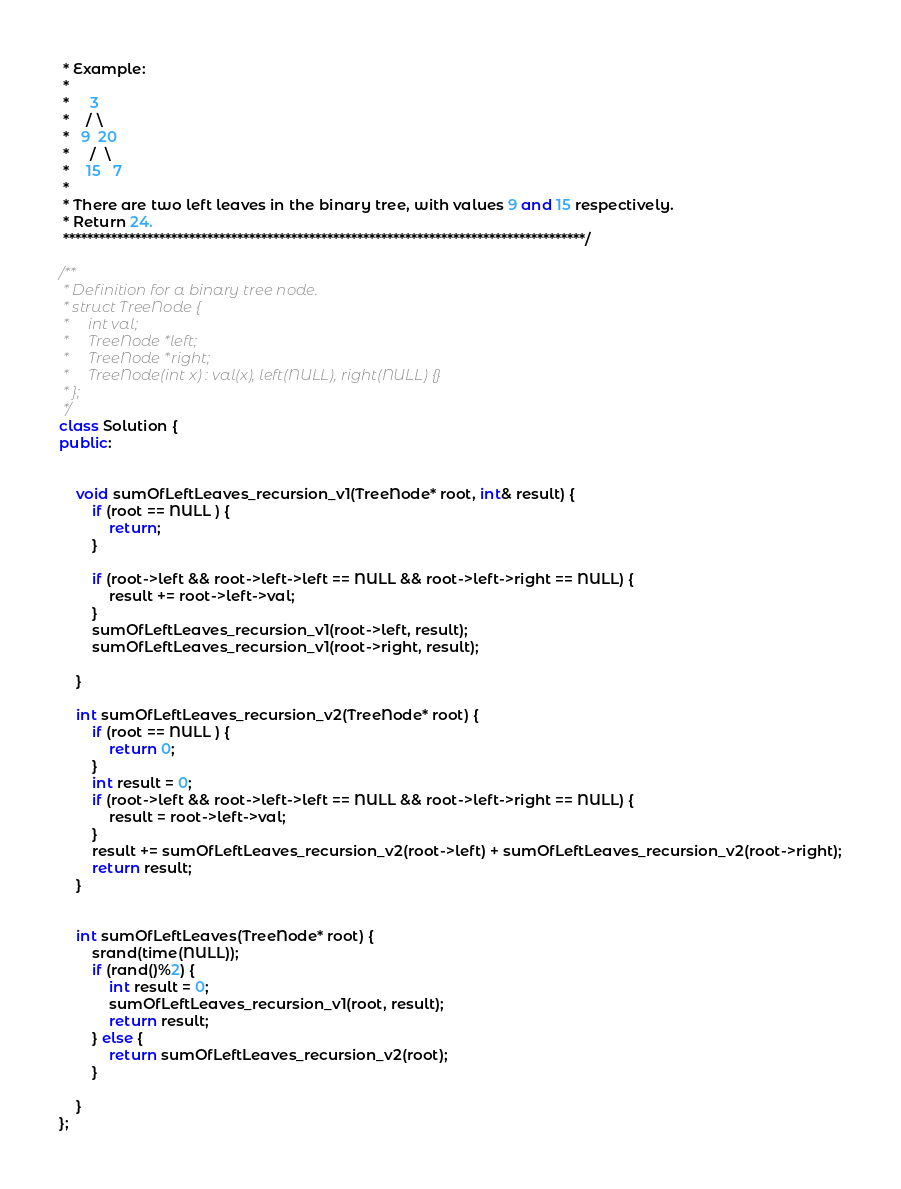Convert code to text. <code><loc_0><loc_0><loc_500><loc_500><_C++_> * Example:
 * 
 *     3
 *    / \
 *   9  20
 *     /  \
 *    15   7
 * 
 * There are two left leaves in the binary tree, with values 9 and 15 respectively. 
 * Return 24.
 ***************************************************************************************/

/**
 * Definition for a binary tree node.
 * struct TreeNode {
 *     int val;
 *     TreeNode *left;
 *     TreeNode *right;
 *     TreeNode(int x) : val(x), left(NULL), right(NULL) {}
 * };
 */
class Solution {
public:

    
    void sumOfLeftLeaves_recursion_v1(TreeNode* root, int& result) {
        if (root == NULL ) {
            return;
        }
        
        if (root->left && root->left->left == NULL && root->left->right == NULL) {
            result += root->left->val;
        }
        sumOfLeftLeaves_recursion_v1(root->left, result);
        sumOfLeftLeaves_recursion_v1(root->right, result);
        
    }
    
    int sumOfLeftLeaves_recursion_v2(TreeNode* root) {
        if (root == NULL ) {
            return 0;
        }
        int result = 0;
        if (root->left && root->left->left == NULL && root->left->right == NULL) {
            result = root->left->val;
        }
        result += sumOfLeftLeaves_recursion_v2(root->left) + sumOfLeftLeaves_recursion_v2(root->right);
        return result;
    }    
    

    int sumOfLeftLeaves(TreeNode* root) {
        srand(time(NULL));
        if (rand()%2) {
            int result = 0;
            sumOfLeftLeaves_recursion_v1(root, result);
            return result;
        } else {
            return sumOfLeftLeaves_recursion_v2(root);
        }
        
    }
};
</code> 